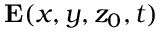<formula> <loc_0><loc_0><loc_500><loc_500>E ( x , y , z _ { 0 } , t )</formula> 